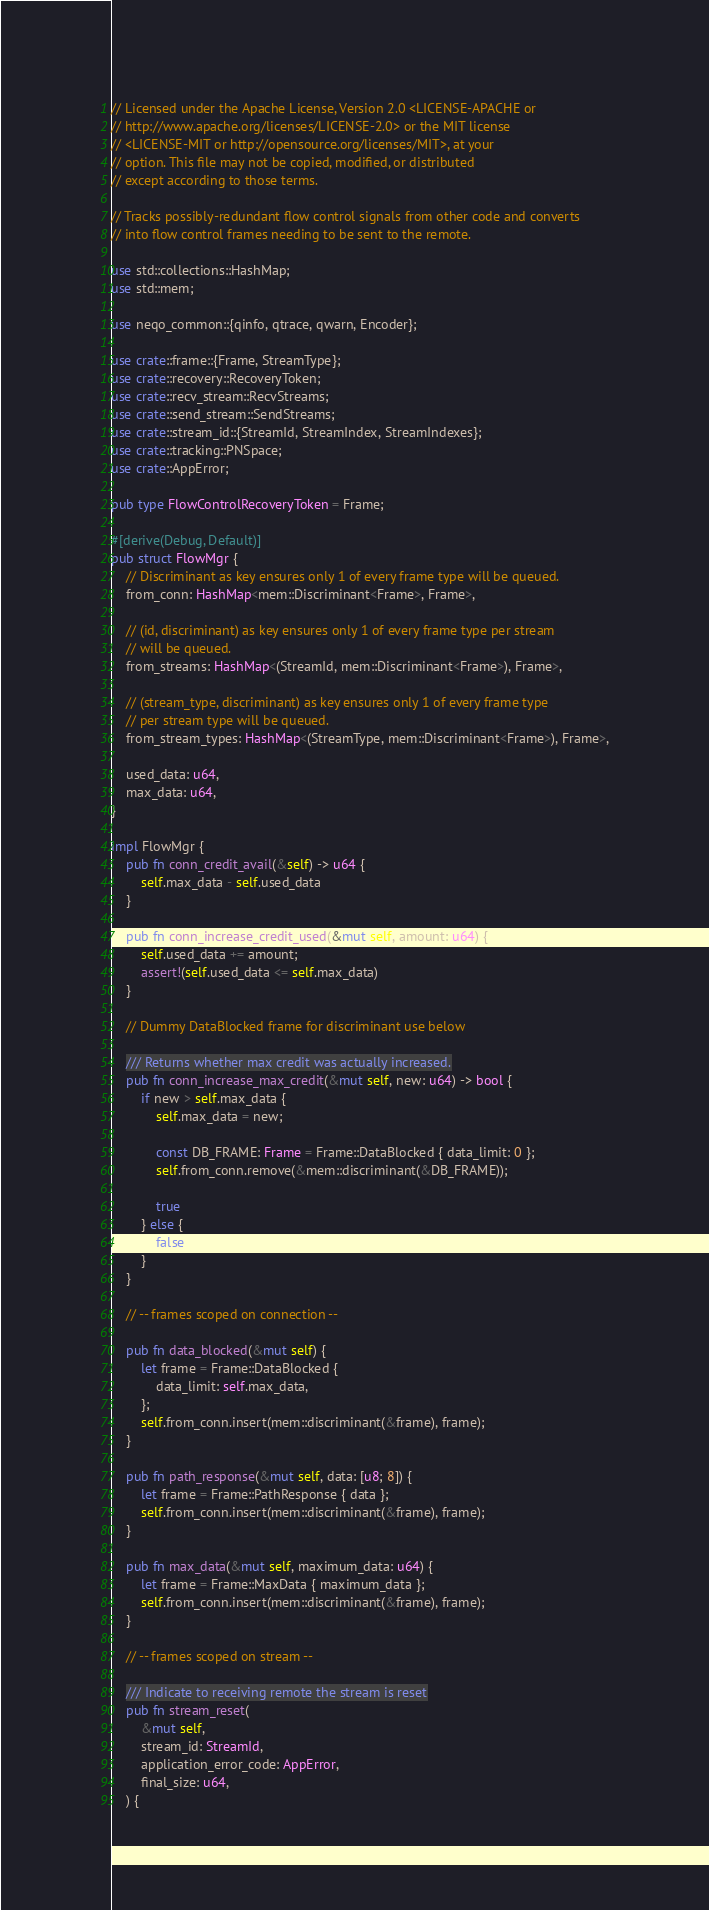Convert code to text. <code><loc_0><loc_0><loc_500><loc_500><_Rust_>// Licensed under the Apache License, Version 2.0 <LICENSE-APACHE or
// http://www.apache.org/licenses/LICENSE-2.0> or the MIT license
// <LICENSE-MIT or http://opensource.org/licenses/MIT>, at your
// option. This file may not be copied, modified, or distributed
// except according to those terms.

// Tracks possibly-redundant flow control signals from other code and converts
// into flow control frames needing to be sent to the remote.

use std::collections::HashMap;
use std::mem;

use neqo_common::{qinfo, qtrace, qwarn, Encoder};

use crate::frame::{Frame, StreamType};
use crate::recovery::RecoveryToken;
use crate::recv_stream::RecvStreams;
use crate::send_stream::SendStreams;
use crate::stream_id::{StreamId, StreamIndex, StreamIndexes};
use crate::tracking::PNSpace;
use crate::AppError;

pub type FlowControlRecoveryToken = Frame;

#[derive(Debug, Default)]
pub struct FlowMgr {
    // Discriminant as key ensures only 1 of every frame type will be queued.
    from_conn: HashMap<mem::Discriminant<Frame>, Frame>,

    // (id, discriminant) as key ensures only 1 of every frame type per stream
    // will be queued.
    from_streams: HashMap<(StreamId, mem::Discriminant<Frame>), Frame>,

    // (stream_type, discriminant) as key ensures only 1 of every frame type
    // per stream type will be queued.
    from_stream_types: HashMap<(StreamType, mem::Discriminant<Frame>), Frame>,

    used_data: u64,
    max_data: u64,
}

impl FlowMgr {
    pub fn conn_credit_avail(&self) -> u64 {
        self.max_data - self.used_data
    }

    pub fn conn_increase_credit_used(&mut self, amount: u64) {
        self.used_data += amount;
        assert!(self.used_data <= self.max_data)
    }

    // Dummy DataBlocked frame for discriminant use below

    /// Returns whether max credit was actually increased.
    pub fn conn_increase_max_credit(&mut self, new: u64) -> bool {
        if new > self.max_data {
            self.max_data = new;

            const DB_FRAME: Frame = Frame::DataBlocked { data_limit: 0 };
            self.from_conn.remove(&mem::discriminant(&DB_FRAME));

            true
        } else {
            false
        }
    }

    // -- frames scoped on connection --

    pub fn data_blocked(&mut self) {
        let frame = Frame::DataBlocked {
            data_limit: self.max_data,
        };
        self.from_conn.insert(mem::discriminant(&frame), frame);
    }

    pub fn path_response(&mut self, data: [u8; 8]) {
        let frame = Frame::PathResponse { data };
        self.from_conn.insert(mem::discriminant(&frame), frame);
    }

    pub fn max_data(&mut self, maximum_data: u64) {
        let frame = Frame::MaxData { maximum_data };
        self.from_conn.insert(mem::discriminant(&frame), frame);
    }

    // -- frames scoped on stream --

    /// Indicate to receiving remote the stream is reset
    pub fn stream_reset(
        &mut self,
        stream_id: StreamId,
        application_error_code: AppError,
        final_size: u64,
    ) {</code> 